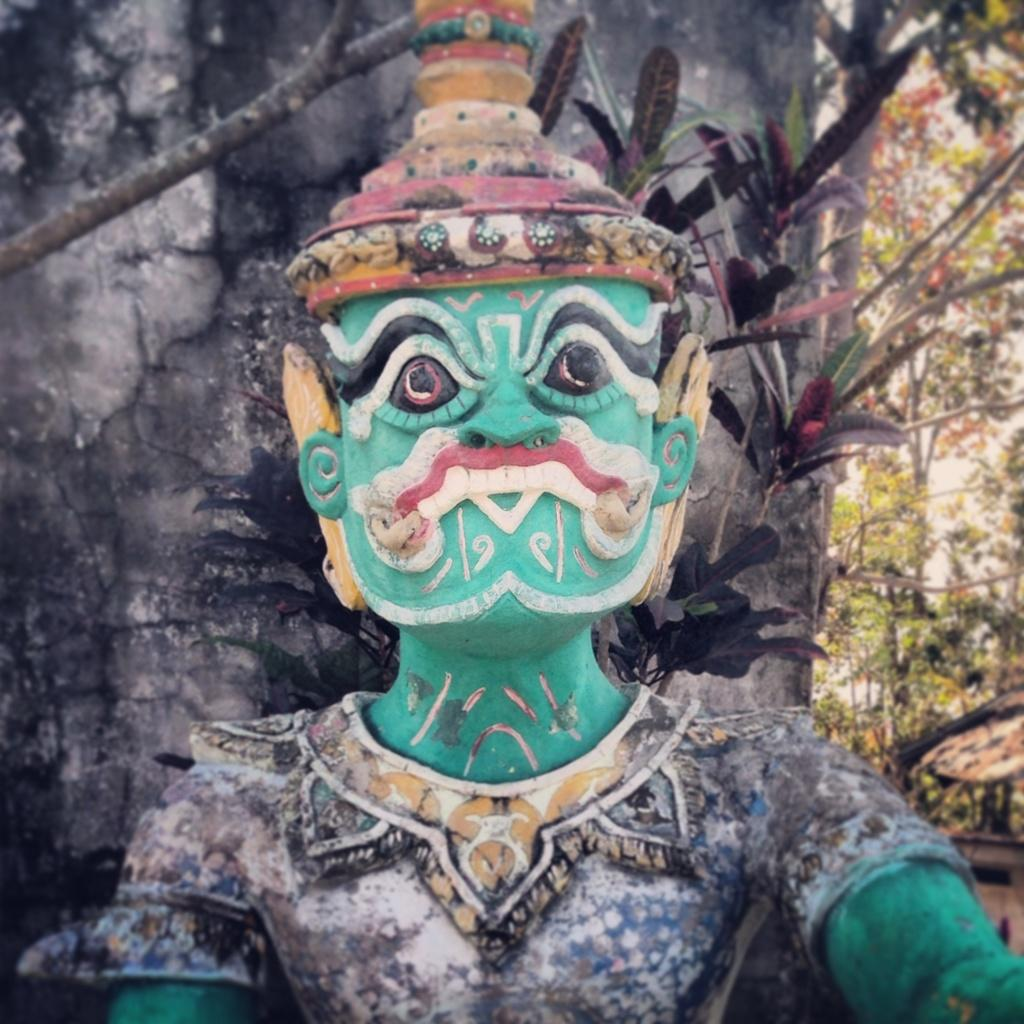What is the main subject in the middle of the image? There is a statue in the middle of the image. What type of vegetation is on the right side of the image? There are trees on the right side of the image. How does the statue show its appreciation to the visitors in the image? There is no indication of visitors in the image, and the statue does not show any emotions or actions that could be interpreted as appreciation. 